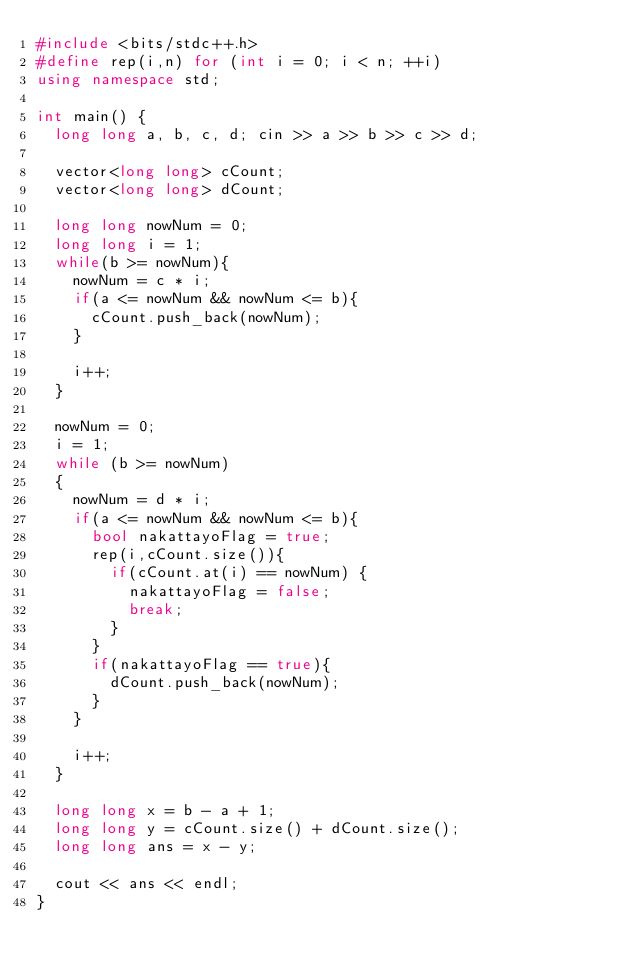Convert code to text. <code><loc_0><loc_0><loc_500><loc_500><_C++_>#include <bits/stdc++.h>
#define rep(i,n) for (int i = 0; i < n; ++i)
using namespace std;

int main() {
  long long a, b, c, d; cin >> a >> b >> c >> d;

  vector<long long> cCount;
  vector<long long> dCount;

  long long nowNum = 0;
  long long i = 1;
  while(b >= nowNum){
    nowNum = c * i;
    if(a <= nowNum && nowNum <= b){
      cCount.push_back(nowNum);
    }

    i++;
  }

  nowNum = 0;
  i = 1;
  while (b >= nowNum)
  {
    nowNum = d * i;
    if(a <= nowNum && nowNum <= b){
      bool nakattayoFlag = true;
      rep(i,cCount.size()){
        if(cCount.at(i) == nowNum) {
          nakattayoFlag = false;
          break;
        }
      }
      if(nakattayoFlag == true){
        dCount.push_back(nowNum);
      }
    }

    i++;
  }
  
  long long x = b - a + 1;
  long long y = cCount.size() + dCount.size();
  long long ans = x - y;

  cout << ans << endl;
}</code> 